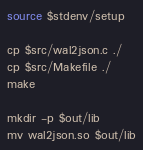Convert code to text. <code><loc_0><loc_0><loc_500><loc_500><_Bash_>source $stdenv/setup

cp $src/wal2json.c ./
cp $src/Makefile ./
make

mkdir -p $out/lib
mv wal2json.so $out/lib
</code> 